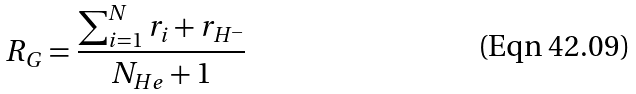Convert formula to latex. <formula><loc_0><loc_0><loc_500><loc_500>R _ { G } = \frac { \sum _ { i = 1 } ^ { N } r _ { i } + r _ { H ^ { - } } } { N _ { H e } + 1 }</formula> 